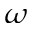<formula> <loc_0><loc_0><loc_500><loc_500>\omega</formula> 